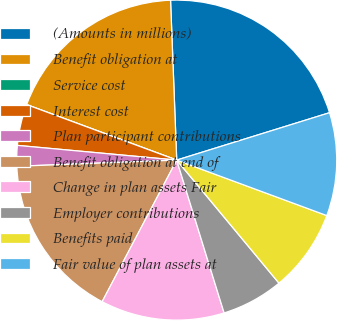Convert chart to OTSL. <chart><loc_0><loc_0><loc_500><loc_500><pie_chart><fcel>(Amounts in millions)<fcel>Benefit obligation at<fcel>Service cost<fcel>Interest cost<fcel>Plan participant contributions<fcel>Benefit obligation at end of<fcel>Change in plan assets Fair<fcel>Employer contributions<fcel>Benefits paid<fcel>Fair value of plan assets at<nl><fcel>20.83%<fcel>18.75%<fcel>0.0%<fcel>4.17%<fcel>2.08%<fcel>16.67%<fcel>12.5%<fcel>6.25%<fcel>8.33%<fcel>10.42%<nl></chart> 